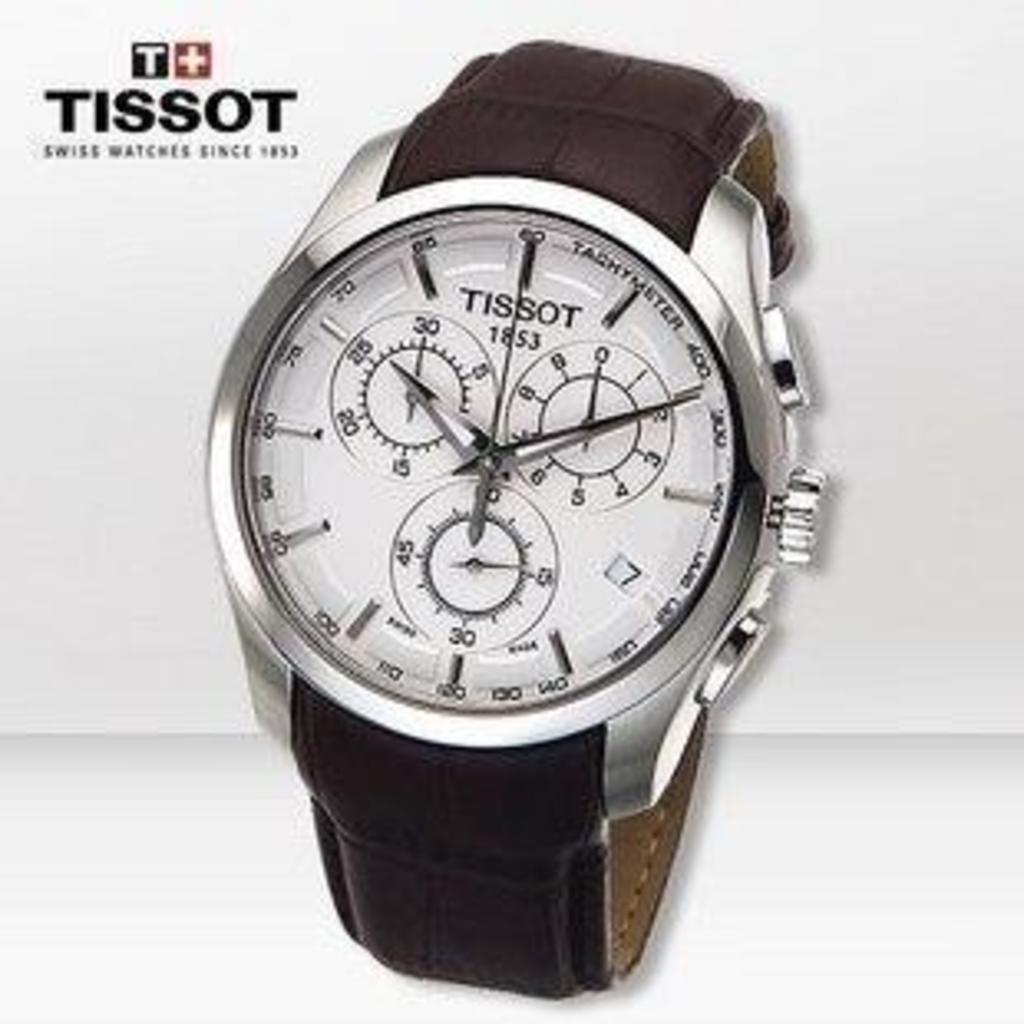<image>
Render a clear and concise summary of the photo. "TISSOT" is on the face of a white and brown watch. 